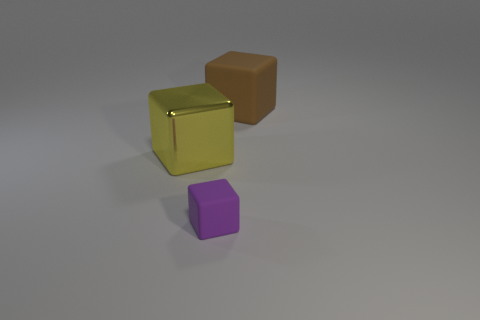There is a big rubber thing that is the same shape as the metallic thing; what color is it?
Keep it short and to the point. Brown. How many objects are tiny yellow spheres or large objects?
Your answer should be very brief. 2. There is a matte thing in front of the large brown cube; does it have the same shape as the large thing in front of the big brown object?
Your answer should be compact. Yes. What is the shape of the thing in front of the yellow shiny block?
Ensure brevity in your answer.  Cube. Are there an equal number of blocks that are in front of the small purple block and big brown rubber cubes that are to the left of the big yellow metal thing?
Your answer should be very brief. Yes. What number of objects are large brown cubes or matte cubes that are in front of the brown matte object?
Offer a very short reply. 2. What is the shape of the thing that is in front of the brown matte block and right of the yellow shiny block?
Provide a succinct answer. Cube. What is the big thing that is right of the large yellow shiny cube that is on the left side of the purple matte block made of?
Your answer should be compact. Rubber. Is the large object left of the brown thing made of the same material as the purple thing?
Ensure brevity in your answer.  No. There is a purple thing in front of the brown block; what size is it?
Keep it short and to the point. Small. 